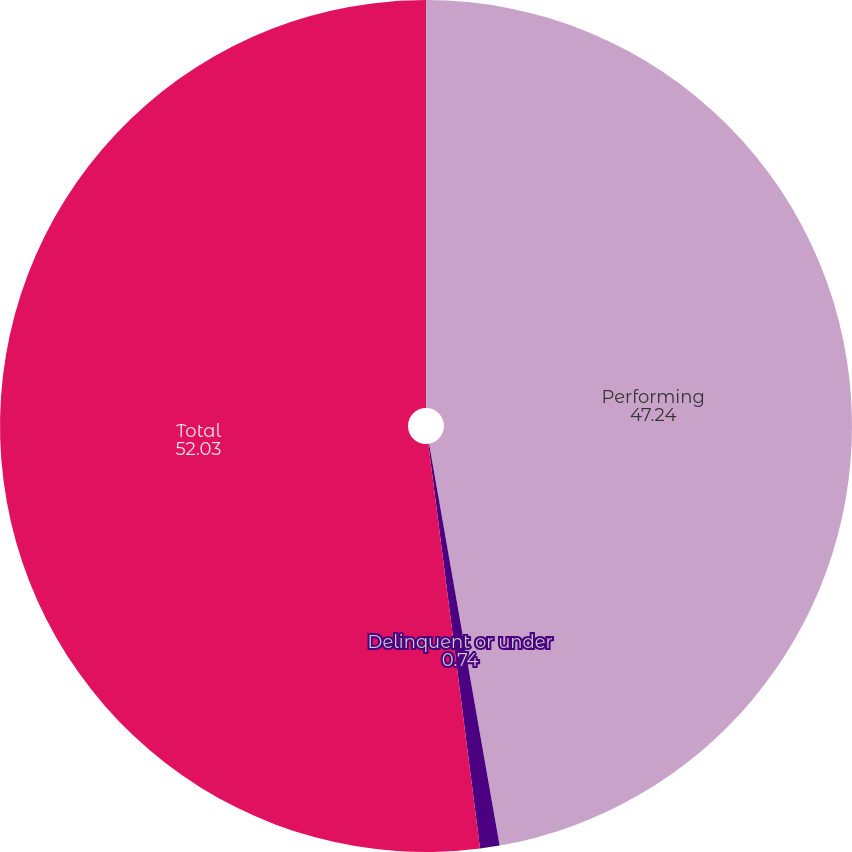Convert chart to OTSL. <chart><loc_0><loc_0><loc_500><loc_500><pie_chart><fcel>Performing<fcel>Delinquent or under<fcel>Total<nl><fcel>47.24%<fcel>0.74%<fcel>52.03%<nl></chart> 